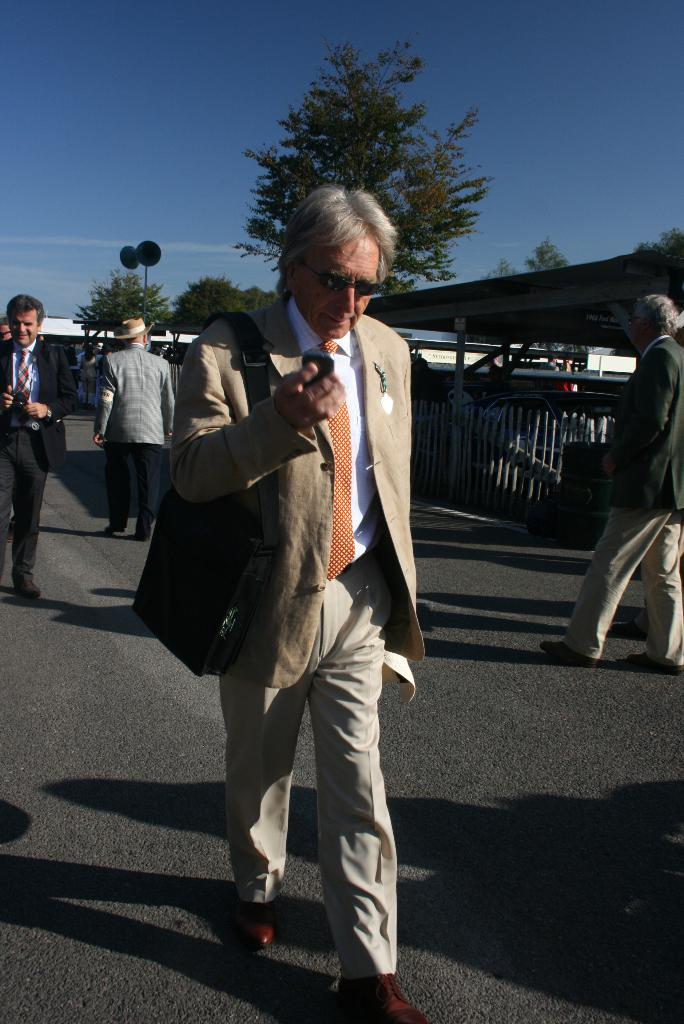How many people are in the image? There is a group of people in the image. What are the people in the image doing? The people are walking on the road. What can be seen in the image besides the people? There is a fence, a shed, and trees in the image. What is visible in the background of the image? The sky with clouds is visible in the background of the image. What type of stone is being used to build the houses in the image? There are no houses present in the image, so it is not possible to determine the type of stone used for construction. 